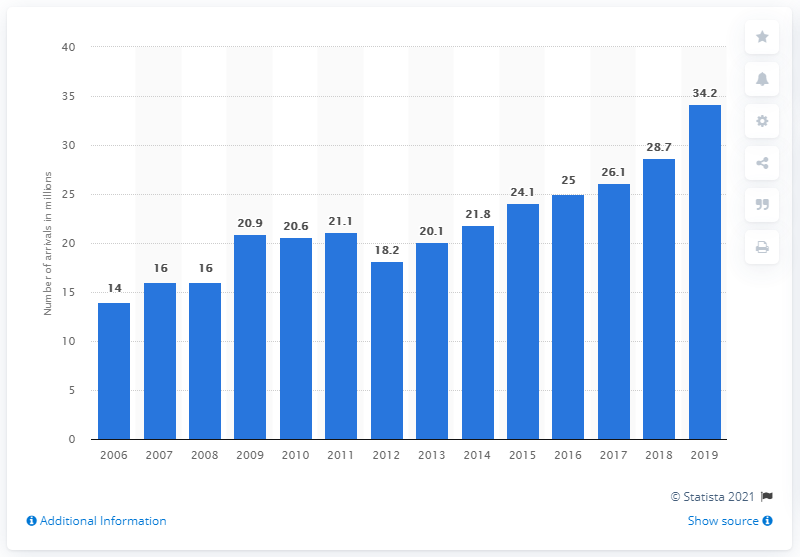Draw attention to some important aspects in this diagram. In 2019, a total of 34.2 arrivals were recorded at travel accommodations in Greece. 